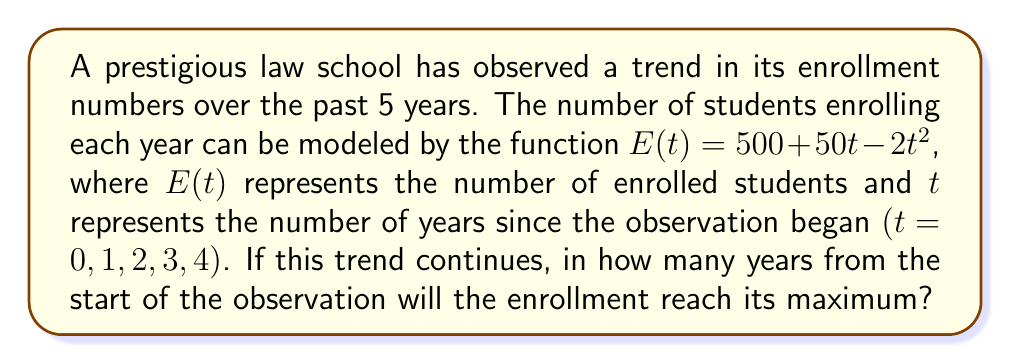Can you answer this question? To find the year when enrollment reaches its maximum, we need to follow these steps:

1) The function $E(t) = 500 + 50t - 2t^2$ is a quadratic function. The maximum of a quadratic function occurs at the vertex of the parabola.

2) For a quadratic function in the form $f(t) = at^2 + bt + c$, the t-coordinate of the vertex is given by $t = -\frac{b}{2a}$.

3) In our case, $a = -2$, $b = 50$, and $c = 500$.

4) Substituting these values into the formula:

   $t = -\frac{50}{2(-2)} = -\frac{50}{-4} = \frac{50}{4} = 12.5$

5) Since $t$ represents years, we need to round this to the nearest whole number. 12.5 rounds up to 13.

Therefore, the enrollment will reach its maximum 13 years from the start of the observation.
Answer: 13 years 